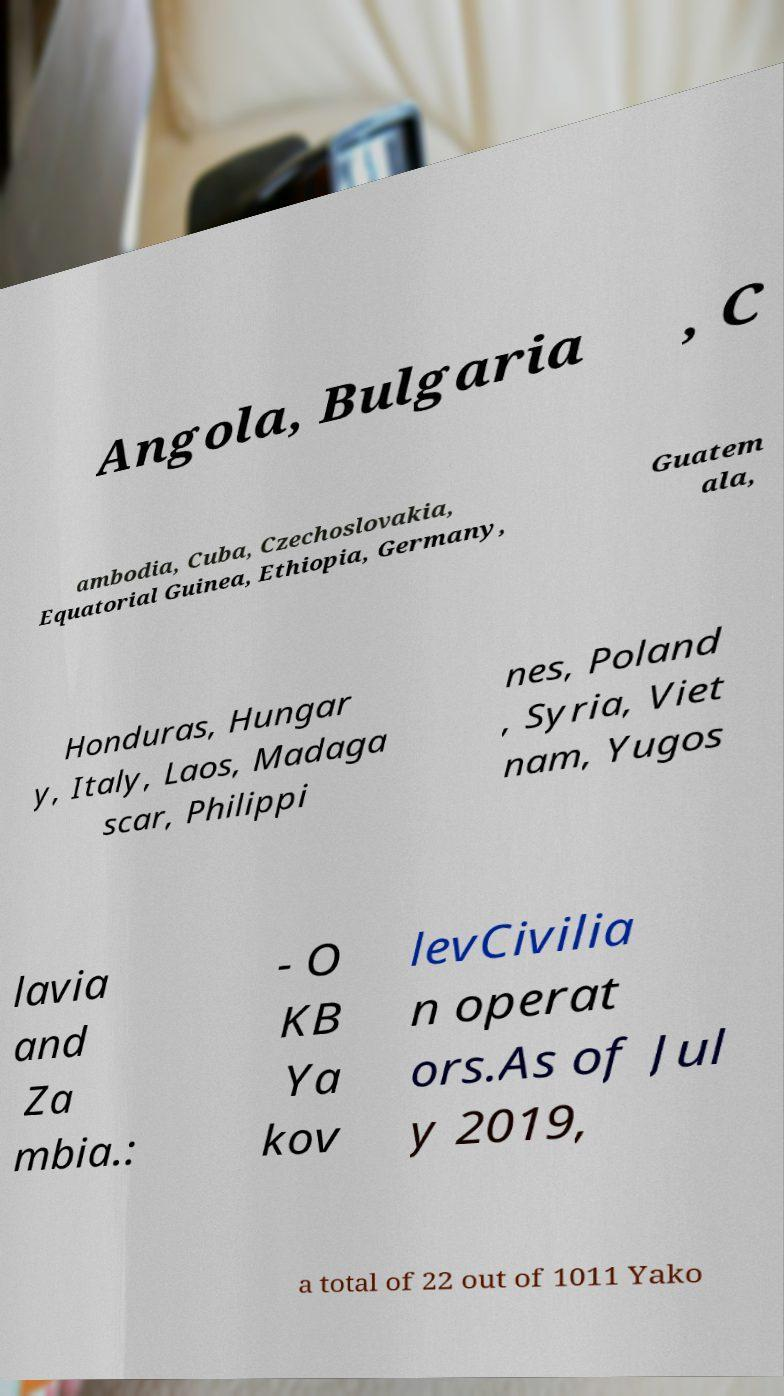Could you assist in decoding the text presented in this image and type it out clearly? Angola, Bulgaria , C ambodia, Cuba, Czechoslovakia, Equatorial Guinea, Ethiopia, Germany, Guatem ala, Honduras, Hungar y, Italy, Laos, Madaga scar, Philippi nes, Poland , Syria, Viet nam, Yugos lavia and Za mbia.: - O KB Ya kov levCivilia n operat ors.As of Jul y 2019, a total of 22 out of 1011 Yako 